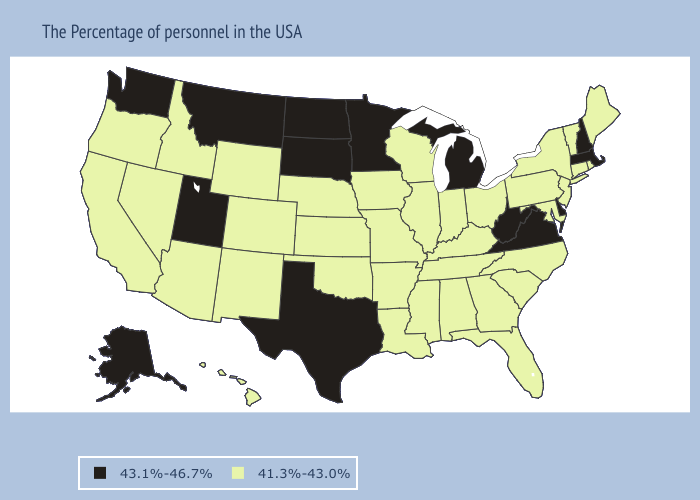Name the states that have a value in the range 43.1%-46.7%?
Keep it brief. Massachusetts, New Hampshire, Delaware, Virginia, West Virginia, Michigan, Minnesota, Texas, South Dakota, North Dakota, Utah, Montana, Washington, Alaska. Name the states that have a value in the range 43.1%-46.7%?
Give a very brief answer. Massachusetts, New Hampshire, Delaware, Virginia, West Virginia, Michigan, Minnesota, Texas, South Dakota, North Dakota, Utah, Montana, Washington, Alaska. Which states have the highest value in the USA?
Answer briefly. Massachusetts, New Hampshire, Delaware, Virginia, West Virginia, Michigan, Minnesota, Texas, South Dakota, North Dakota, Utah, Montana, Washington, Alaska. What is the lowest value in the USA?
Keep it brief. 41.3%-43.0%. What is the value of Illinois?
Concise answer only. 41.3%-43.0%. What is the value of Washington?
Give a very brief answer. 43.1%-46.7%. What is the value of Nebraska?
Write a very short answer. 41.3%-43.0%. Name the states that have a value in the range 41.3%-43.0%?
Write a very short answer. Maine, Rhode Island, Vermont, Connecticut, New York, New Jersey, Maryland, Pennsylvania, North Carolina, South Carolina, Ohio, Florida, Georgia, Kentucky, Indiana, Alabama, Tennessee, Wisconsin, Illinois, Mississippi, Louisiana, Missouri, Arkansas, Iowa, Kansas, Nebraska, Oklahoma, Wyoming, Colorado, New Mexico, Arizona, Idaho, Nevada, California, Oregon, Hawaii. Does New Hampshire have the highest value in the USA?
Keep it brief. Yes. What is the value of Virginia?
Short answer required. 43.1%-46.7%. What is the value of Connecticut?
Keep it brief. 41.3%-43.0%. Which states have the highest value in the USA?
Write a very short answer. Massachusetts, New Hampshire, Delaware, Virginia, West Virginia, Michigan, Minnesota, Texas, South Dakota, North Dakota, Utah, Montana, Washington, Alaska. What is the value of Oregon?
Short answer required. 41.3%-43.0%. Name the states that have a value in the range 41.3%-43.0%?
Give a very brief answer. Maine, Rhode Island, Vermont, Connecticut, New York, New Jersey, Maryland, Pennsylvania, North Carolina, South Carolina, Ohio, Florida, Georgia, Kentucky, Indiana, Alabama, Tennessee, Wisconsin, Illinois, Mississippi, Louisiana, Missouri, Arkansas, Iowa, Kansas, Nebraska, Oklahoma, Wyoming, Colorado, New Mexico, Arizona, Idaho, Nevada, California, Oregon, Hawaii. Among the states that border Tennessee , does Mississippi have the highest value?
Give a very brief answer. No. 